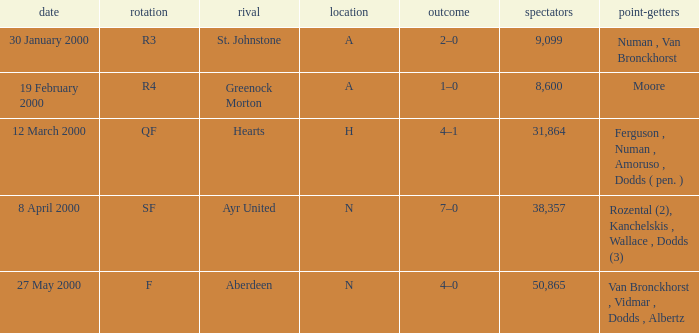What venue was on 27 May 2000? N. 